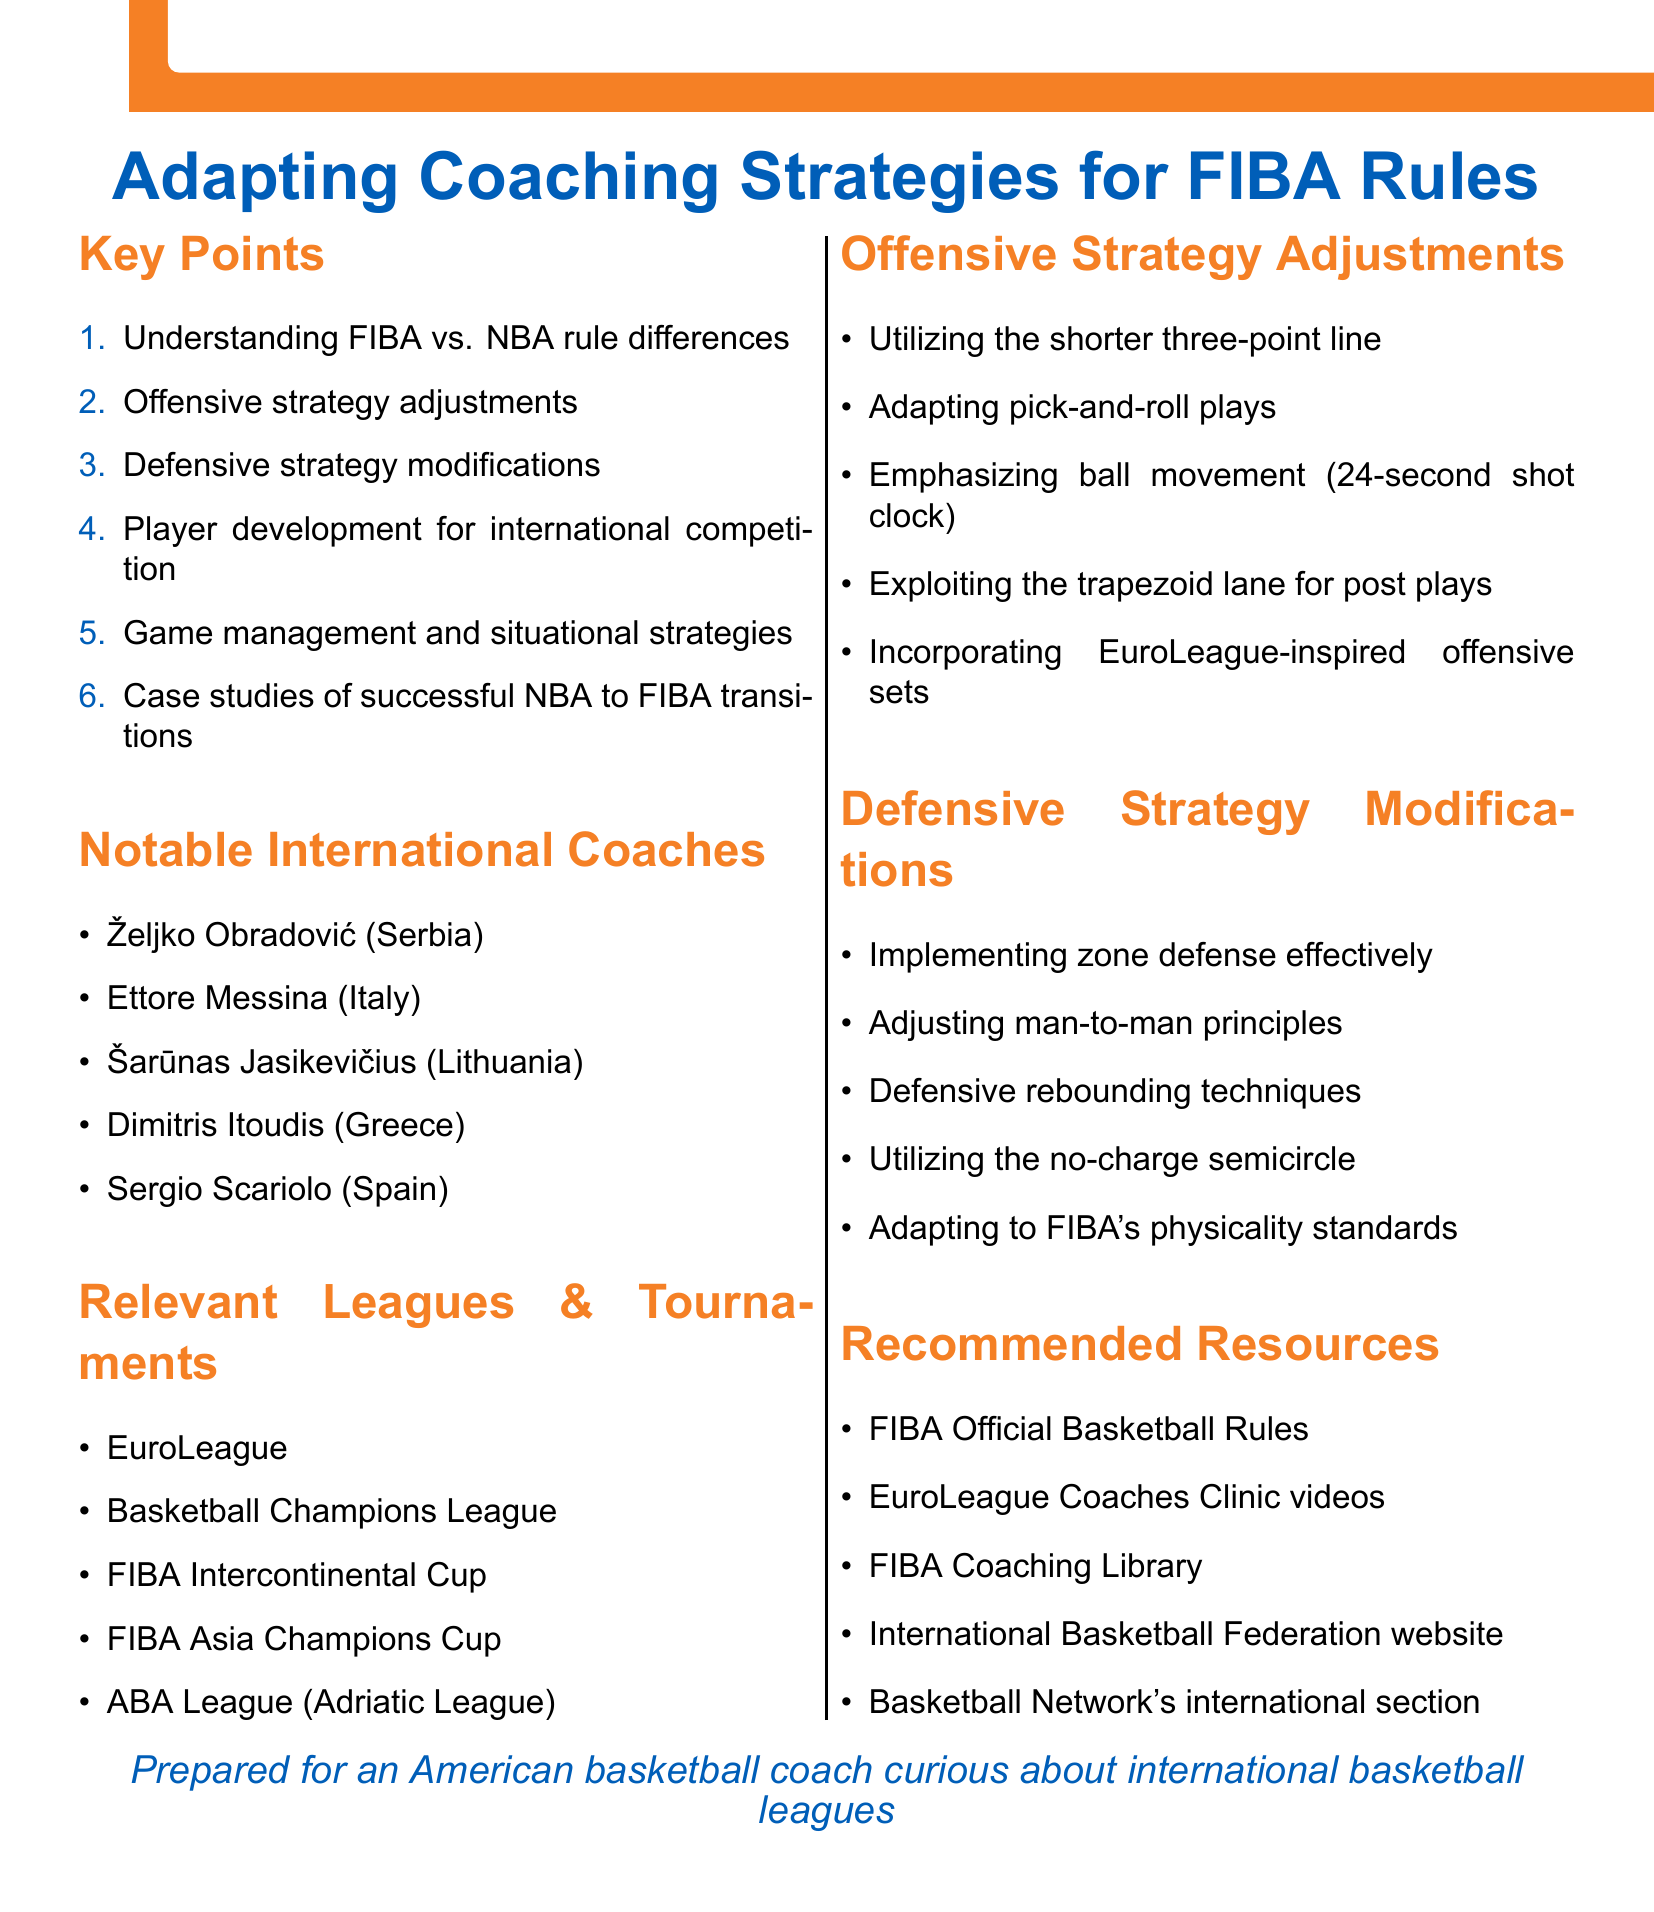What are the key points discussed in the document? The document lists the main topics under "Key Points" which include understanding rule differences, offensive adjustments, defensive modifications, player development, game management, and case studies.
Answer: Six Who is one notable international coach mentioned? The document provides a list of notable international coaches with their countries. One example is Željko Obradović from Serbia.
Answer: Željko Obradović What is one recommended resource listed? The document includes several recommended resources; one of them is the FIBA Official Basketball Rules.
Answer: FIBA Official Basketball Rules How many relevant leagues and tournaments are mentioned? The document lists five different leagues and tournaments under that section.
Answer: Five What is a focus of the offensive strategy adjustments? The document mentions several focuses, such as "utilizing the shorter three-point line" as part of the offensive strategy adjustments.
Answer: Utilizing the shorter three-point line What rule difference involves the time management aspect? One important aspect of time management in FIBA rules is the "game duration and time management."
Answer: Game duration and time management Which section focuses on preparing players for international play? The section titled "Player development for international competition" focuses on this topic.
Answer: Player development for international competition In which section would you find information about zone defense? The section titled "Defensive strategy modifications" includes details about implementing zone defense effectively.
Answer: Defensive strategy modifications 